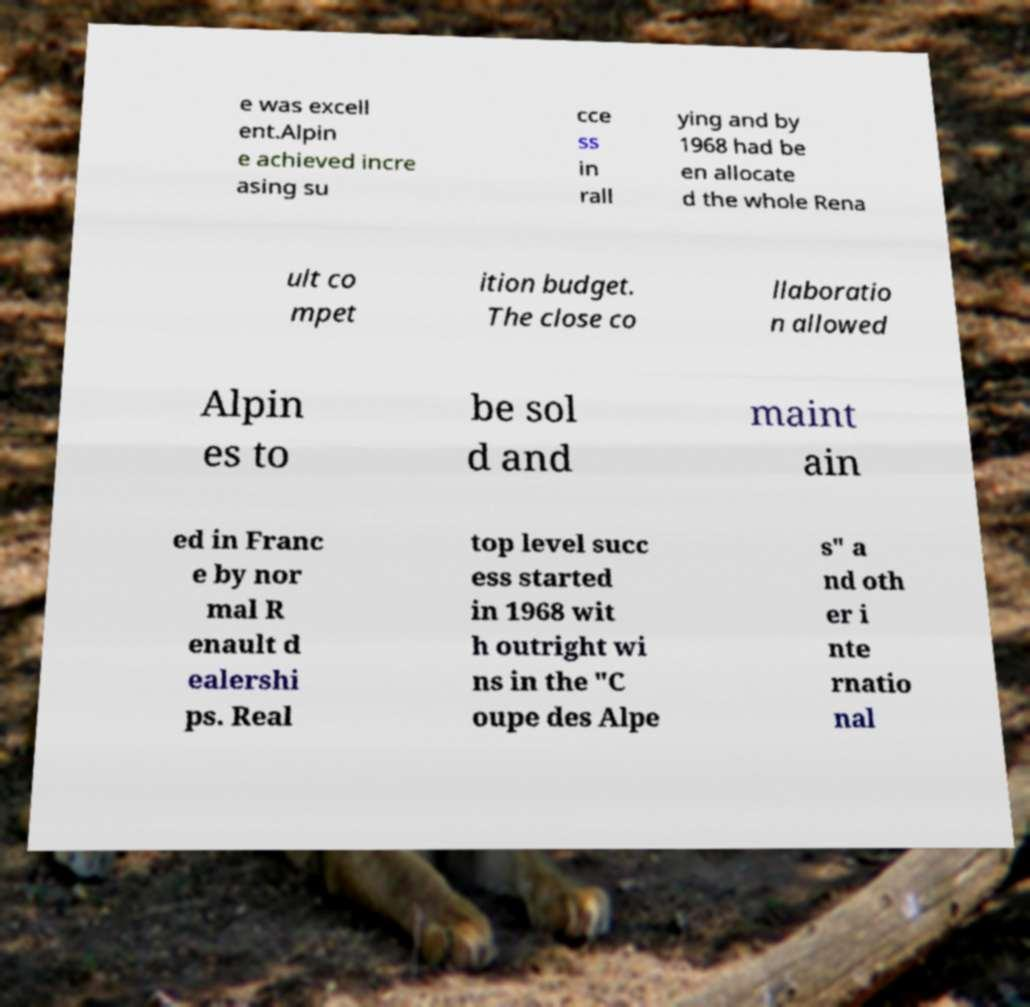Can you accurately transcribe the text from the provided image for me? e was excell ent.Alpin e achieved incre asing su cce ss in rall ying and by 1968 had be en allocate d the whole Rena ult co mpet ition budget. The close co llaboratio n allowed Alpin es to be sol d and maint ain ed in Franc e by nor mal R enault d ealershi ps. Real top level succ ess started in 1968 wit h outright wi ns in the "C oupe des Alpe s" a nd oth er i nte rnatio nal 